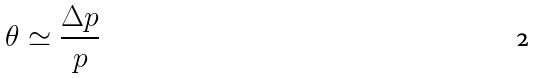<formula> <loc_0><loc_0><loc_500><loc_500>\theta \simeq \frac { \Delta p } { p }</formula> 